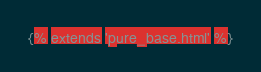Convert code to text. <code><loc_0><loc_0><loc_500><loc_500><_CSS_>{% extends 'pure_base.html' %}</code> 